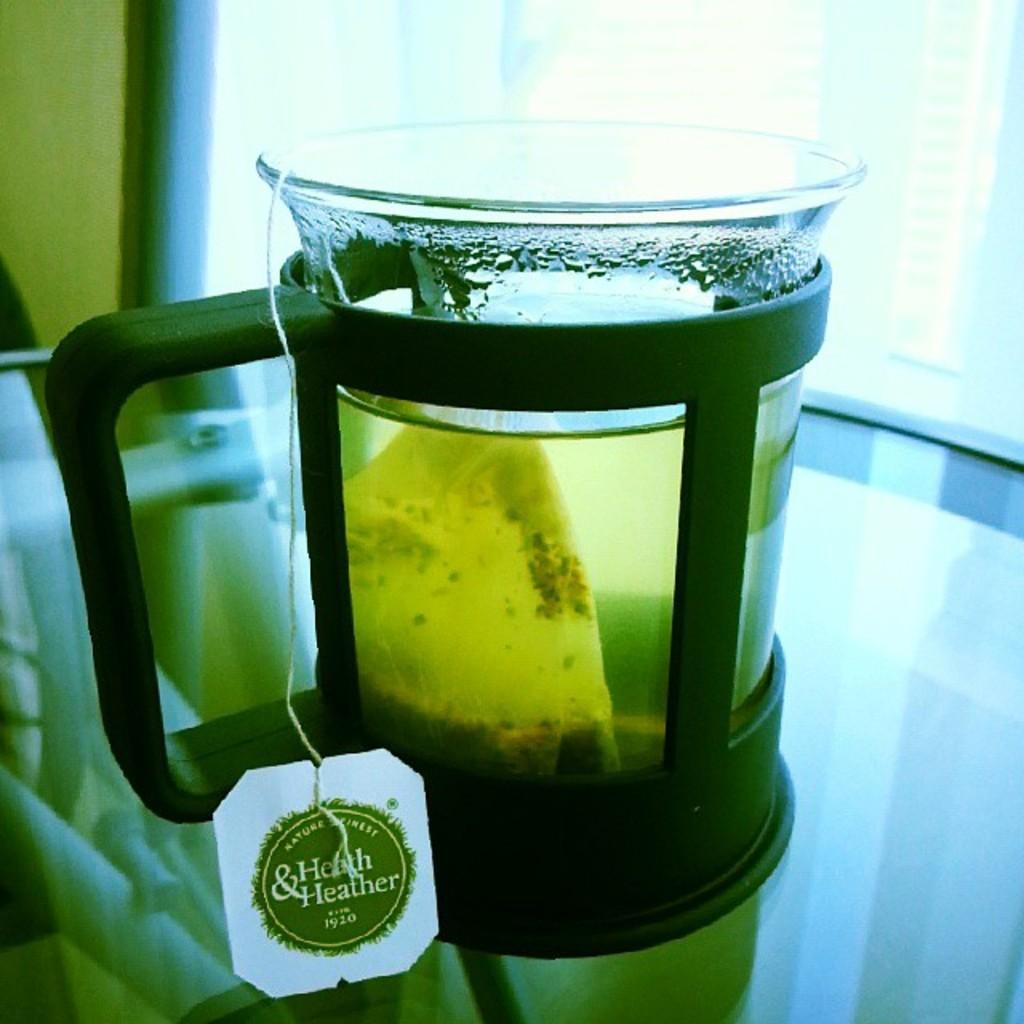What is inside the glass jar in the image? There is a glass jar containing tea in the image. Where is the glass jar located? The glass jar is placed on a table. What can be seen in the background of the image? There is a glass window in the background of the image. How does the tea in the jar express anger in the image? The tea in the jar does not express anger, as it is an inanimate object and cannot display emotions. 